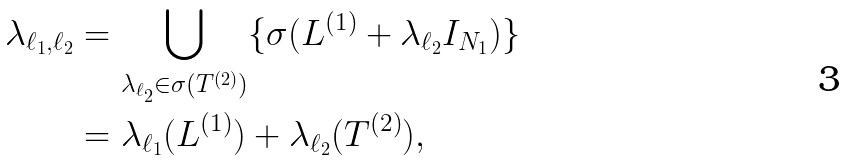<formula> <loc_0><loc_0><loc_500><loc_500>\lambda _ { \ell _ { 1 } , \ell _ { 2 } } & = \bigcup _ { \lambda _ { \ell _ { 2 } } \in \sigma ( T ^ { ( 2 ) } ) } \{ \sigma ( L ^ { ( 1 ) } + \lambda _ { \ell _ { 2 } } I _ { N _ { 1 } } ) \} \\ & = \lambda _ { \ell _ { 1 } } ( L ^ { ( 1 ) } ) + \lambda _ { \ell _ { 2 } } ( T ^ { ( 2 ) } ) ,</formula> 